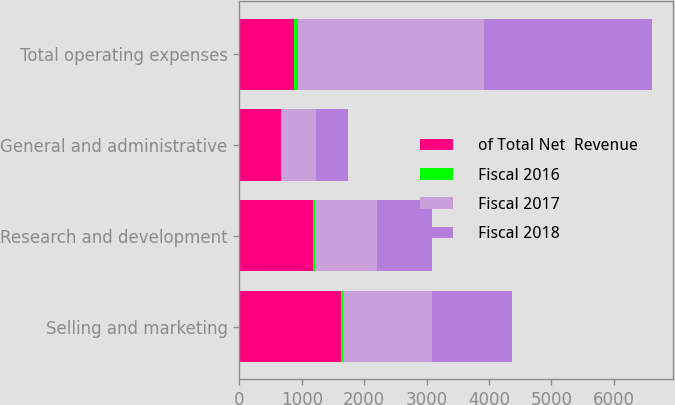<chart> <loc_0><loc_0><loc_500><loc_500><stacked_bar_chart><ecel><fcel>Selling and marketing<fcel>Research and development<fcel>General and administrative<fcel>Total operating expenses<nl><fcel>of Total Net  Revenue<fcel>1634<fcel>1186<fcel>664<fcel>881<nl><fcel>Fiscal 2016<fcel>27<fcel>20<fcel>11<fcel>58<nl><fcel>Fiscal 2017<fcel>1420<fcel>998<fcel>553<fcel>2973<nl><fcel>Fiscal 2018<fcel>1289<fcel>881<fcel>518<fcel>2700<nl></chart> 